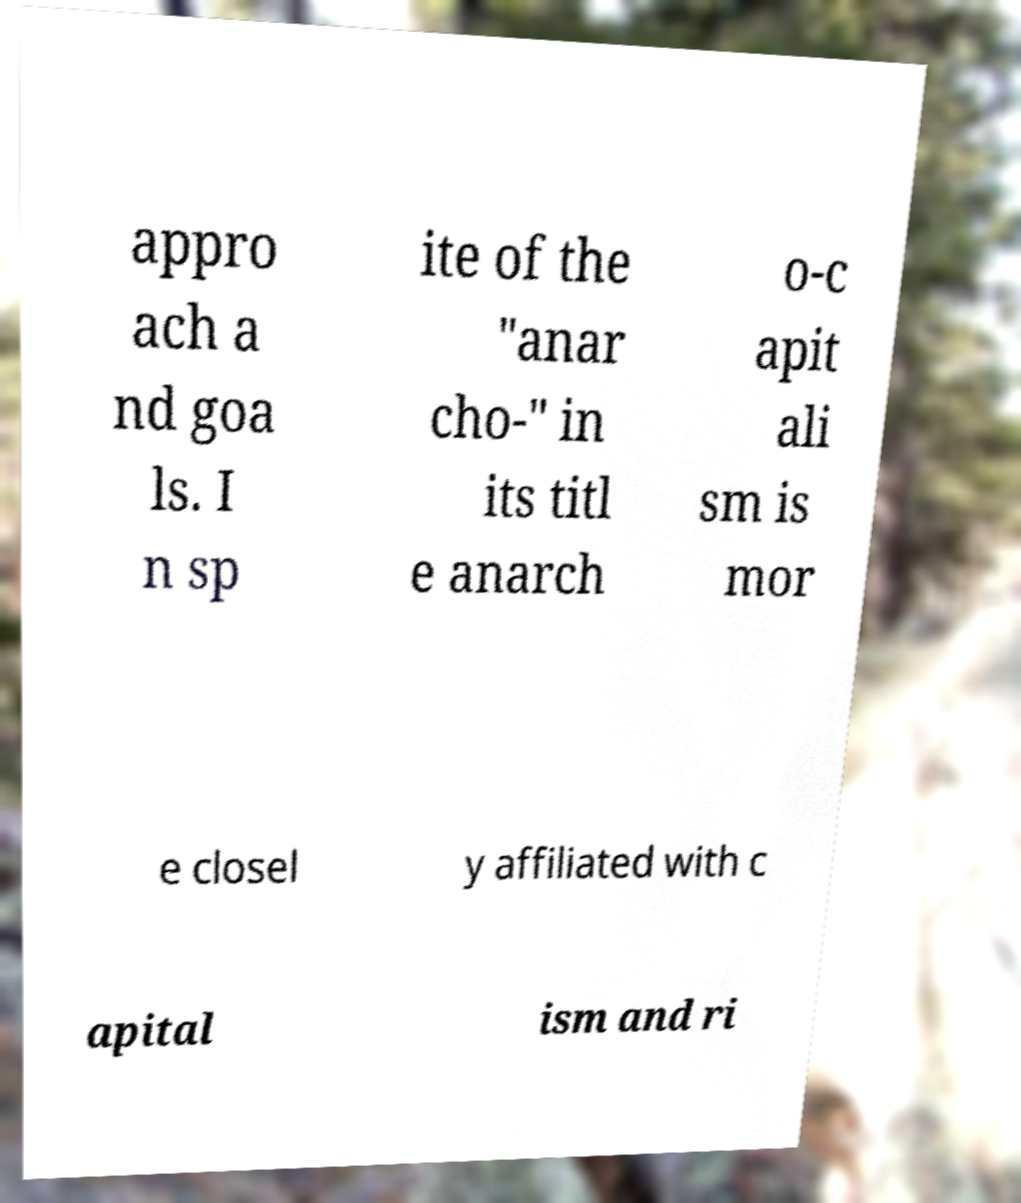Please read and relay the text visible in this image. What does it say? appro ach a nd goa ls. I n sp ite of the "anar cho-" in its titl e anarch o-c apit ali sm is mor e closel y affiliated with c apital ism and ri 